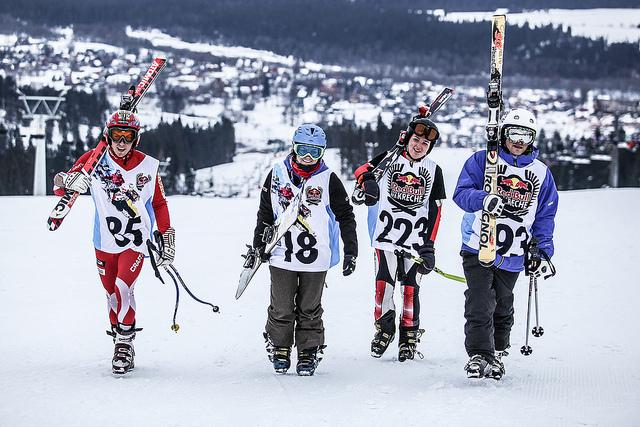How many of the 4 kids are holding skies? three 